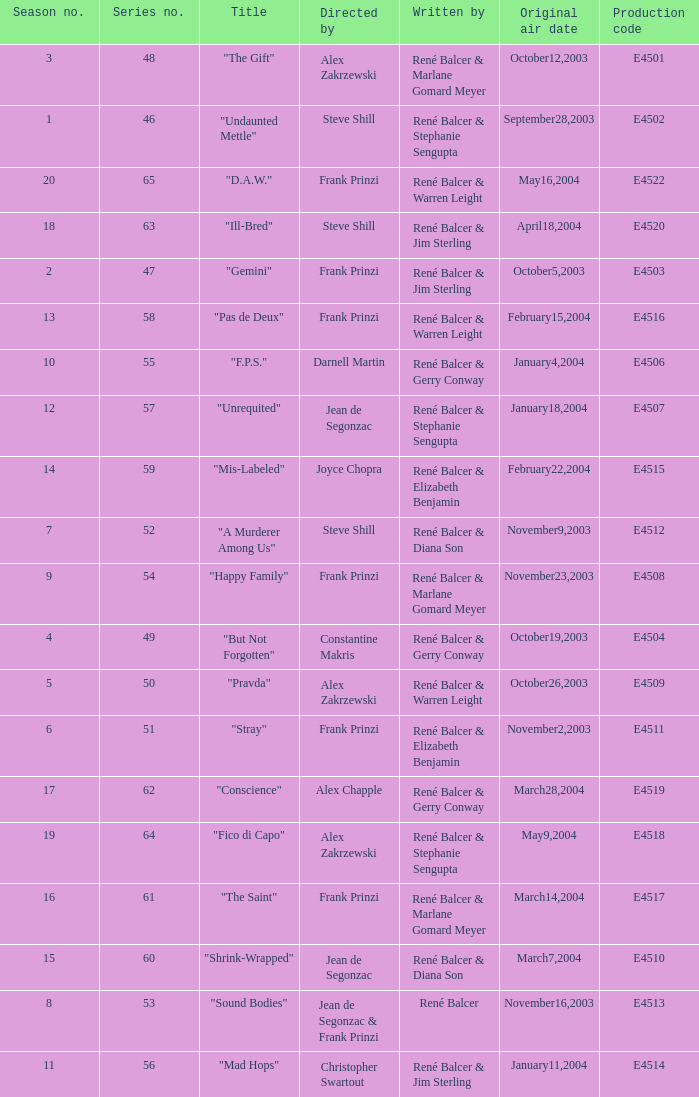Who wrote the episode with e4515 as the production code? René Balcer & Elizabeth Benjamin. 